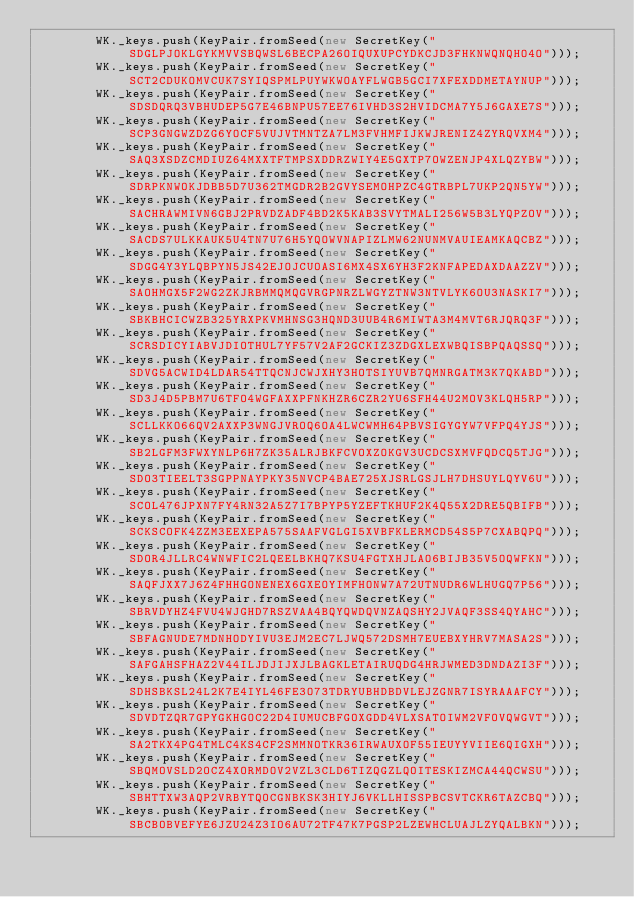Convert code to text. <code><loc_0><loc_0><loc_500><loc_500><_TypeScript_>        WK._keys.push(KeyPair.fromSeed(new SecretKey("SDGLPJOKLGYKMVVSBQWSL6BECPA26OIQUXUPCYDKCJD3FHKNWQNQHO4O")));
        WK._keys.push(KeyPair.fromSeed(new SecretKey("SCT2CDUKOMVCUK7SYIQSPMLPUYWKWOAYFLWGB5GCI7XFEXDDMETAYNUP")));
        WK._keys.push(KeyPair.fromSeed(new SecretKey("SDSDQRQ3VBHUDEP5G7E46BNPU57EE76IVHD3S2HVIDCMA7Y5J6GAXE7S")));
        WK._keys.push(KeyPair.fromSeed(new SecretKey("SCP3GNGWZDZG6YOCF5VUJVTMNTZA7LM3FVHMFIJKWJRENIZ4ZYRQVXM4")));
        WK._keys.push(KeyPair.fromSeed(new SecretKey("SAQ3XSDZCMDIUZ64MXXTFTMPSXDDRZWIY4E5GXTP7OWZENJP4XLQZYBW")));
        WK._keys.push(KeyPair.fromSeed(new SecretKey("SDRPKNWOKJDBB5D7U362TMGDR2B2GVYSEMOHPZC4GTRBPL7UKP2QN5YW")));
        WK._keys.push(KeyPair.fromSeed(new SecretKey("SACHRAWMIVN6GBJ2PRVDZADF4BD2K5KAB3SVYTMALI256W5B3LYQPZOV")));
        WK._keys.push(KeyPair.fromSeed(new SecretKey("SACDS7ULKKAUK5U4TN7U76H5YQOWVNAPIZLMW62NUNMVAUIEAMKAQCBZ")));
        WK._keys.push(KeyPair.fromSeed(new SecretKey("SDGG4Y3YLQBPYN5JS42EJOJCUOASI6MX4SX6YH3F2KNFAPEDAXDAAZZV")));
        WK._keys.push(KeyPair.fromSeed(new SecretKey("SAOHMGX5F2WG2ZKJRBMMQMQGVRGPNRZLWGYZTNW3NTVLYK6OU3NASKI7")));
        WK._keys.push(KeyPair.fromSeed(new SecretKey("SBKBHCICWZB325YRXPKVMHNSG3HQND3UUB4R6MIWTA3M4MVT6RJQRQ3F")));
        WK._keys.push(KeyPair.fromSeed(new SecretKey("SCRSDICYIABVJDIOTHUL7YF57V2AF2GCKIZ3ZDGXLEXWBQISBPQAQSSQ")));
        WK._keys.push(KeyPair.fromSeed(new SecretKey("SDVG5ACWID4LDAR54TTQCNJCWJXHY3HOTSIYUVB7QMNRGATM3K7QKABD")));
        WK._keys.push(KeyPair.fromSeed(new SecretKey("SD3J4D5PBM7U6TFO4WGFAXXPFNKHZR6CZR2YU6SFH44U2MOV3KLQH5RP")));
        WK._keys.push(KeyPair.fromSeed(new SecretKey("SCLLKKO66QV2AXXP3WNGJVROQ6OA4LWCWMH64PBVSIGYGYW7VFPQ4YJS")));
        WK._keys.push(KeyPair.fromSeed(new SecretKey("SB2LGFM3FWXYNLP6H7ZK35ALRJBKFCVOXZOKGV3UCDCSXMVFQDCQ5TJG")));
        WK._keys.push(KeyPair.fromSeed(new SecretKey("SDO3TIEELT3SGPPNAYPKY35NVCP4BAE725XJSRLGSJLH7DHSUYLQYV6U")));
        WK._keys.push(KeyPair.fromSeed(new SecretKey("SCOL476JPXN7FY4RN32A5Z7I7BPYP5YZEFTKHUF2K4Q55X2DRE5QBIFB")));
        WK._keys.push(KeyPair.fromSeed(new SecretKey("SCKSCOFK4ZZM3EEXEPA575SAAFVGLGI5XVBFKLERMCD54S5P7CXABQPQ")));
        WK._keys.push(KeyPair.fromSeed(new SecretKey("SDOR4JLLRC4WNWFIC2LQEELBKHQ7KSU4FGTXHJLAO6BIJB35V5OQWFKN")));
        WK._keys.push(KeyPair.fromSeed(new SecretKey("SAQFJXX7J6Z4FHHGONENEX6GXEOYIMFHONW7A72UTNUDR6WLHUGQ7P56")));
        WK._keys.push(KeyPair.fromSeed(new SecretKey("SBRVDYHZ4FVU4WJGHD7RSZVAA4BQYQWDQVNZAQSHY2JVAQF3SS4QYAHC")));
        WK._keys.push(KeyPair.fromSeed(new SecretKey("SBFAGNUDE7MDNHODYIVU3EJM2EC7LJWQ572DSMH7EUEBXYHRV7MASA2S")));
        WK._keys.push(KeyPair.fromSeed(new SecretKey("SAFGAHSFHAZ2V44ILJDJIJXJLBAGKLETAIRUQDG4HRJWMED3DNDAZI3F")));
        WK._keys.push(KeyPair.fromSeed(new SecretKey("SDHSBKSL24L2K7E4IYL46FE3O73TDRYUBHDBDVLEJZGNR7ISYRAAAFCY")));
        WK._keys.push(KeyPair.fromSeed(new SecretKey("SDVDTZQR7GPYGKHGOC22D4IUMUCBFGOXGDD4VLXSATOIWM2VFOVQWGVT")));
        WK._keys.push(KeyPair.fromSeed(new SecretKey("SA2TKX4PG4TMLC4KS4CF2SMMNOTKR36IRWAUXOF55IEUYYVIIE6QIGXH")));
        WK._keys.push(KeyPair.fromSeed(new SecretKey("SBQMOVSLD2OCZ4XORMDOV2VZL3CLD6TIZQGZLQOITESKIZMCA44QCWSU")));
        WK._keys.push(KeyPair.fromSeed(new SecretKey("SBHTTXW3AQP2VRBYTQOCGNBKSK3HIYJ6VKLLHISSPBCSVTCKR6TAZCBQ")));
        WK._keys.push(KeyPair.fromSeed(new SecretKey("SBCBOBVEFYE6JZU24Z3IO6AU72TF47K7PGSP2LZEWHCLUAJLZYQALBKN")));</code> 